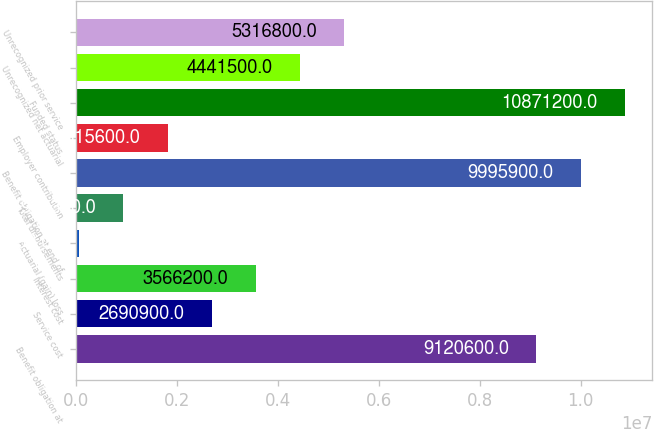Convert chart. <chart><loc_0><loc_0><loc_500><loc_500><bar_chart><fcel>Benefit obligation at<fcel>Service cost<fcel>Interest cost<fcel>Actuarial (gain) loss<fcel>Total disbursements<fcel>Benefit obligation at end of<fcel>Employer contribution<fcel>Funded status<fcel>Unrecognized net actuarial<fcel>Unrecognized prior service<nl><fcel>9.1206e+06<fcel>2.6909e+06<fcel>3.5662e+06<fcel>65000<fcel>940300<fcel>9.9959e+06<fcel>1.8156e+06<fcel>1.08712e+07<fcel>4.4415e+06<fcel>5.3168e+06<nl></chart> 